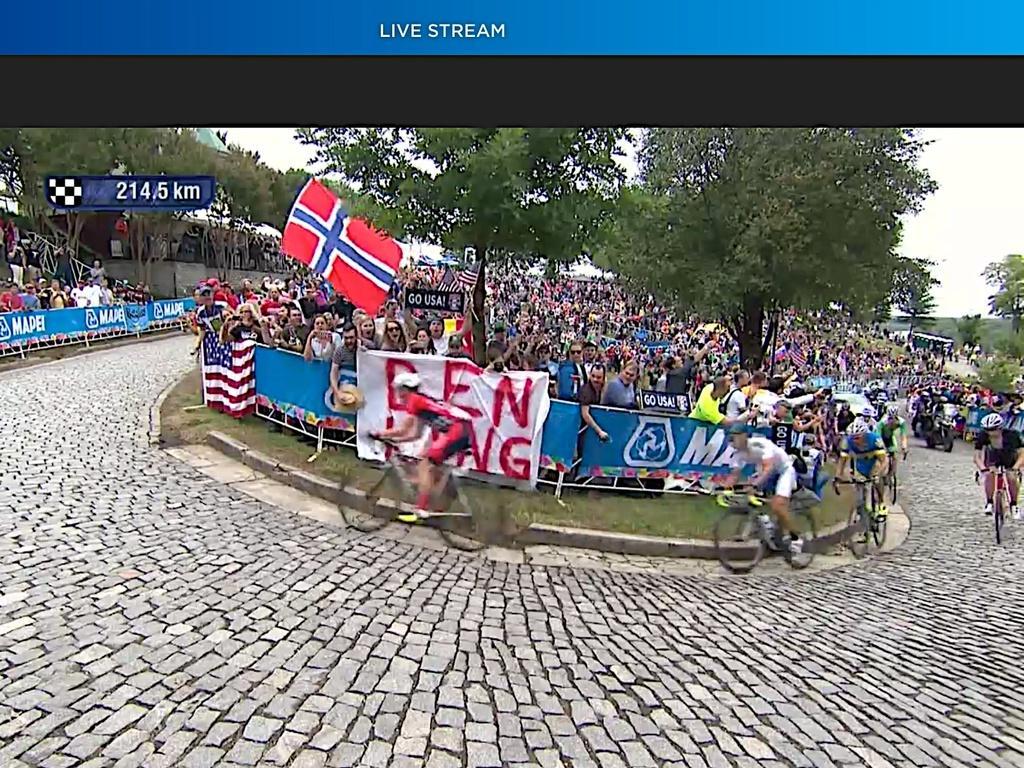In one or two sentences, can you explain what this image depicts? In this image there are group of persons riding bicycles, there are persons riding motorcycle, there are group of audience, there is a flag, there are boards, there is text on the board, there is a number, there are trees, there is the sky, there is text towards the top of the image. 